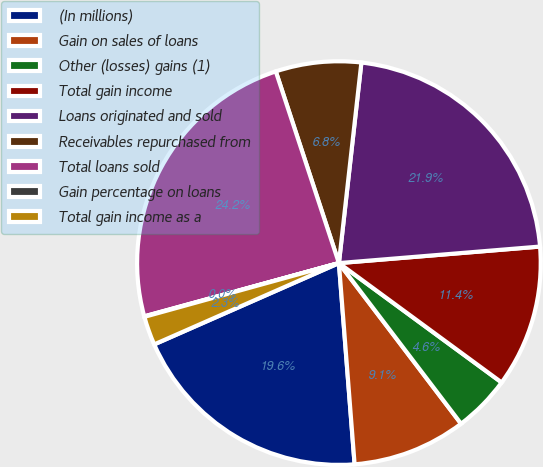<chart> <loc_0><loc_0><loc_500><loc_500><pie_chart><fcel>(In millions)<fcel>Gain on sales of loans<fcel>Other (losses) gains (1)<fcel>Total gain income<fcel>Loans originated and sold<fcel>Receivables repurchased from<fcel>Total loans sold<fcel>Gain percentage on loans<fcel>Total gain income as a<nl><fcel>19.64%<fcel>9.11%<fcel>4.58%<fcel>11.38%<fcel>21.92%<fcel>6.84%<fcel>24.19%<fcel>0.04%<fcel>2.31%<nl></chart> 